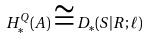Convert formula to latex. <formula><loc_0><loc_0><loc_500><loc_500>H ^ { Q } _ { * } ( A ) \cong D _ { * } ( S | R ; \ell )</formula> 